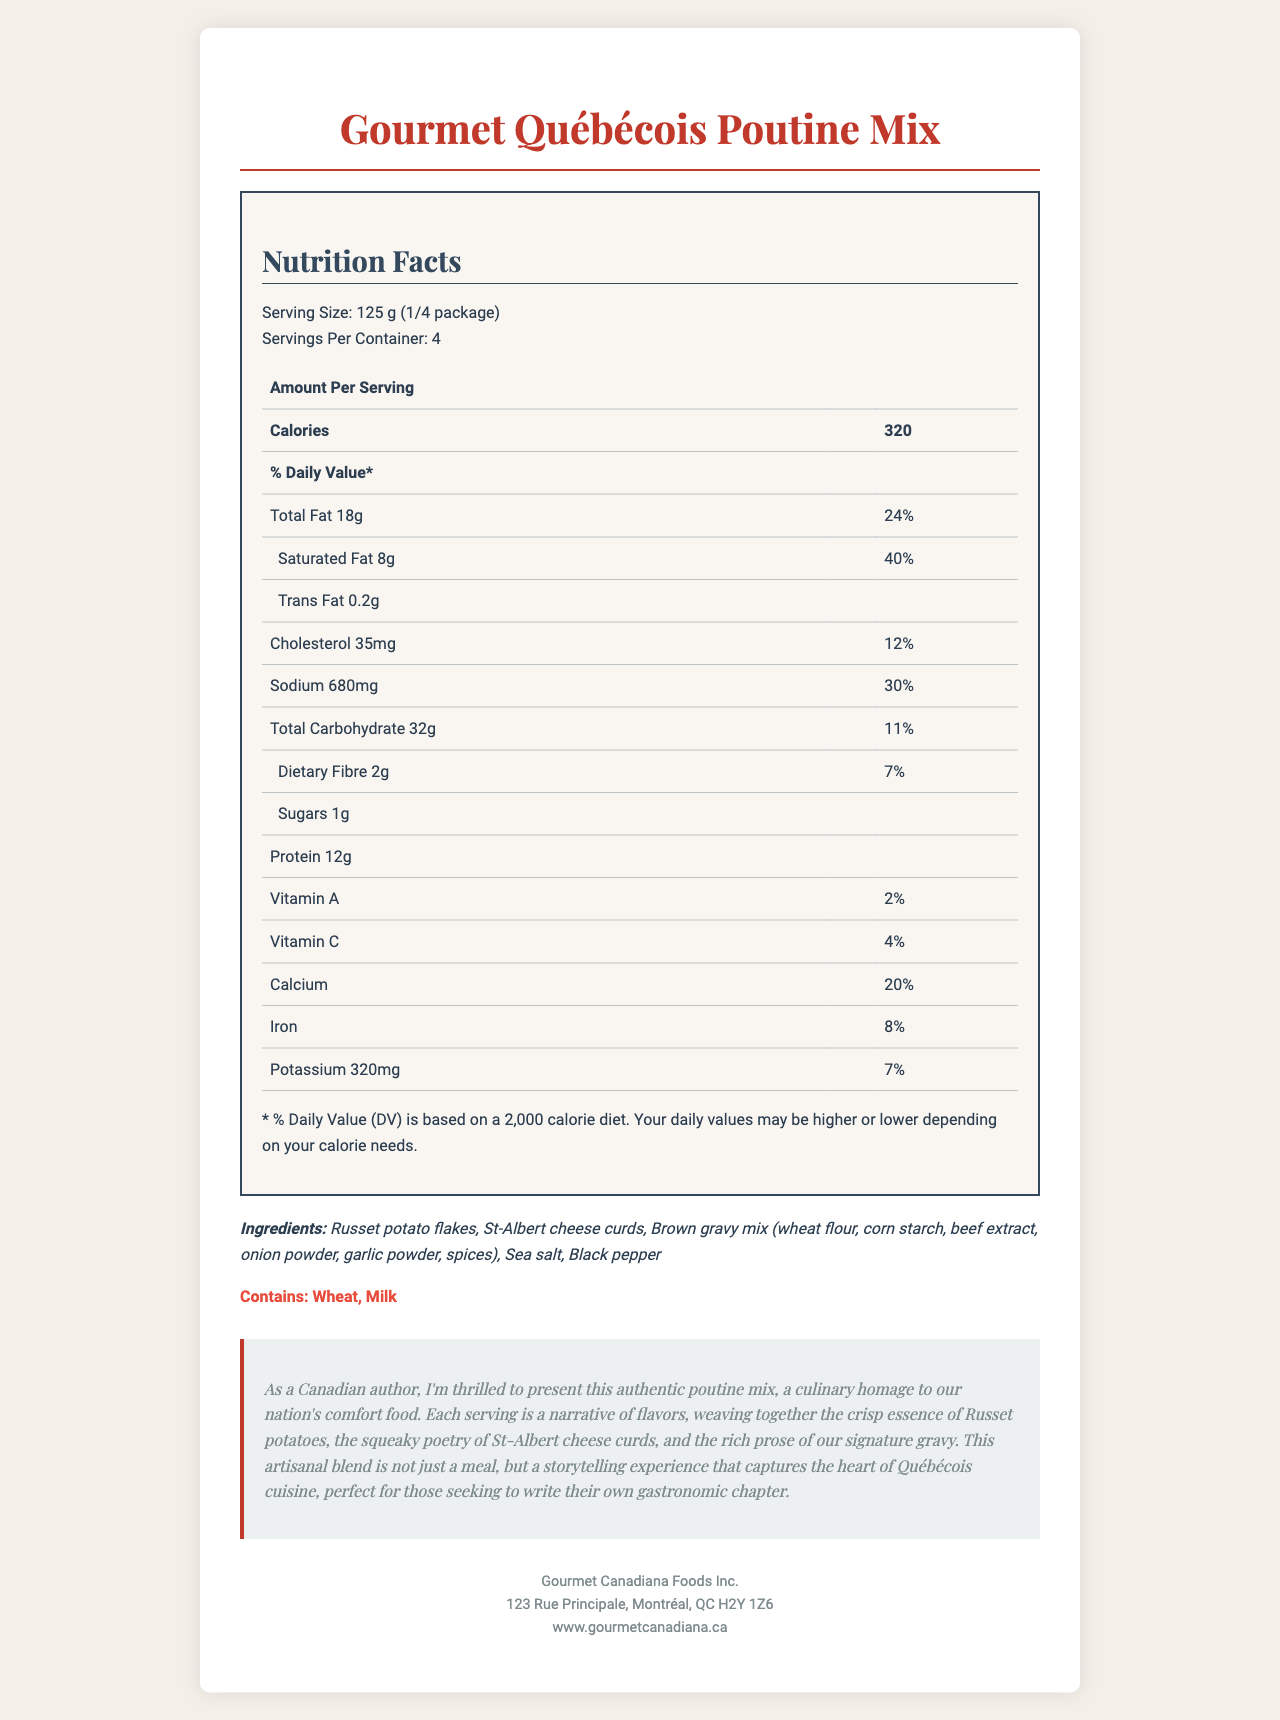what is the serving size? The serving size is clearly stated in the nutrition facts section.
Answer: 125 g (1/4 package) how many servings are in the container? The document specifies that there are 4 servings per container.
Answer: 4 how many calories are in one serving? The calories per serving are mentioned in the nutrition facts.
Answer: 320 how much sodium is in one serving? The amount of sodium per serving is listed in the nutrition facts.
Answer: 680 mg what percentage of the daily value for total carbohydrate does one serving provide? The total carbohydrate daily value percentage is listed in the nutritional information.
Answer: 11% what ingredients are found in the product? The ingredients are listed in the ingredients section.
Answer: Russet potato flakes, St-Albert cheese curds, Brown gravy mix, Sea salt, Black pepper which allergens are present in the product? The allergens are explicitly stated in the allergens section.
Answer: Wheat, Milk which vitamins are included and what are their daily values? A. Vitamin A - 2%, Vitamin C - 4%, Calcium - 20%, Iron - 8% B. Vitamin A - 4%, Vitamin C - 2%, Calcium - 8%, Iron - 20% C. Vitamin A - 2%, Vitamin C - 8%, Calcium - 4%, Iron - 20% The document provides the daily values for vitamins A, C, calcium, and iron.
Answer: A how much protein is in one serving? A. 10 g B. 12 g C. 15 g D. 18 g The protein content is listed as 12 g per serving in the nutrition facts.
Answer: B is this poutine mix regulated by Health Canada? The document states that the product is Health Canada regulated.
Answer: Yes describe the main idea of the document. The document aims to inform consumers about the nutritional values, ingredients, and company details of the poutine mix while also delivering a poetic description that connects the product to Canadian culinary traditions.
Answer: The document provides detailed nutritional information, ingredients, allergens, and company information for the "Gourmet Québécois Poutine Mix" along with a literary description of the product's cultural significance. what are the exact amounts in mg of calcium and iron in the product? The document only provides the daily value percentages for calcium (20%) and iron (8%), not the exact amounts in mg.
Answer: Not enough information 